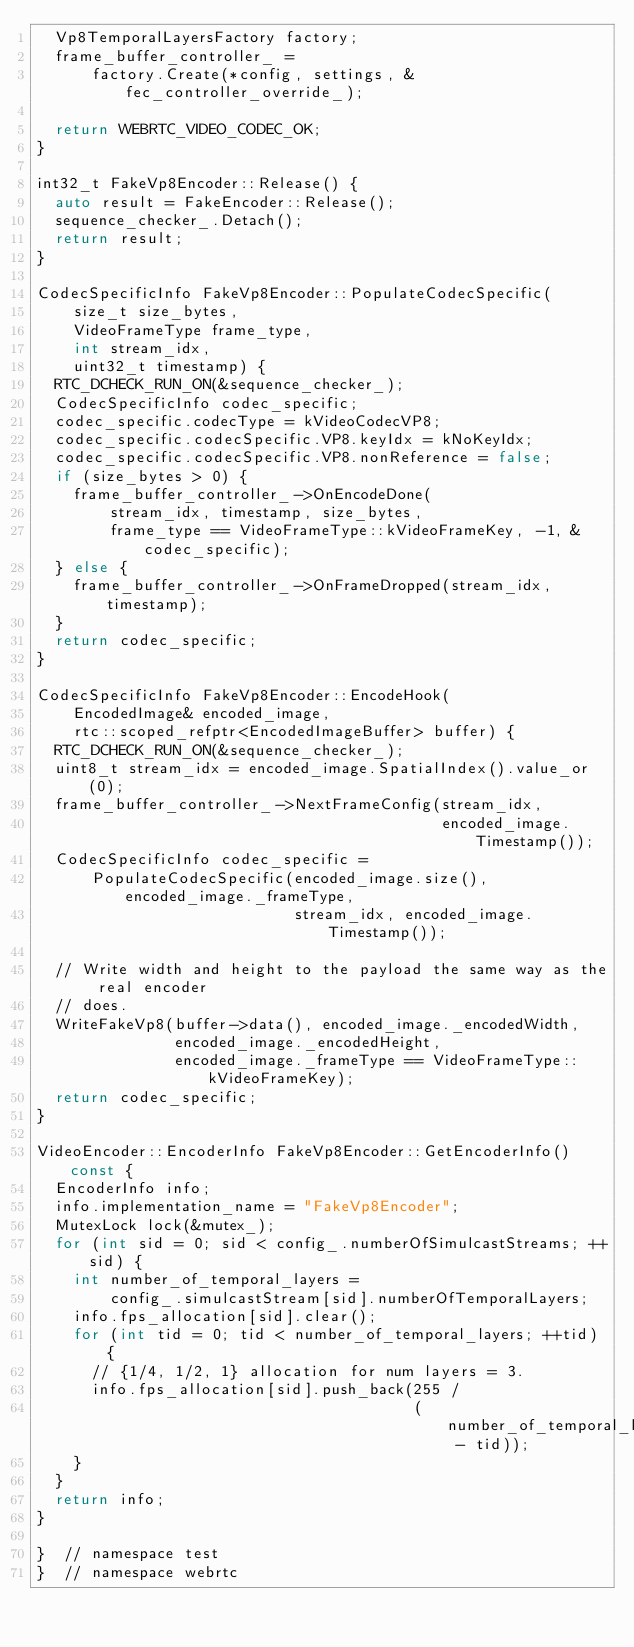Convert code to text. <code><loc_0><loc_0><loc_500><loc_500><_C++_>  Vp8TemporalLayersFactory factory;
  frame_buffer_controller_ =
      factory.Create(*config, settings, &fec_controller_override_);

  return WEBRTC_VIDEO_CODEC_OK;
}

int32_t FakeVp8Encoder::Release() {
  auto result = FakeEncoder::Release();
  sequence_checker_.Detach();
  return result;
}

CodecSpecificInfo FakeVp8Encoder::PopulateCodecSpecific(
    size_t size_bytes,
    VideoFrameType frame_type,
    int stream_idx,
    uint32_t timestamp) {
  RTC_DCHECK_RUN_ON(&sequence_checker_);
  CodecSpecificInfo codec_specific;
  codec_specific.codecType = kVideoCodecVP8;
  codec_specific.codecSpecific.VP8.keyIdx = kNoKeyIdx;
  codec_specific.codecSpecific.VP8.nonReference = false;
  if (size_bytes > 0) {
    frame_buffer_controller_->OnEncodeDone(
        stream_idx, timestamp, size_bytes,
        frame_type == VideoFrameType::kVideoFrameKey, -1, &codec_specific);
  } else {
    frame_buffer_controller_->OnFrameDropped(stream_idx, timestamp);
  }
  return codec_specific;
}

CodecSpecificInfo FakeVp8Encoder::EncodeHook(
    EncodedImage& encoded_image,
    rtc::scoped_refptr<EncodedImageBuffer> buffer) {
  RTC_DCHECK_RUN_ON(&sequence_checker_);
  uint8_t stream_idx = encoded_image.SpatialIndex().value_or(0);
  frame_buffer_controller_->NextFrameConfig(stream_idx,
                                            encoded_image.Timestamp());
  CodecSpecificInfo codec_specific =
      PopulateCodecSpecific(encoded_image.size(), encoded_image._frameType,
                            stream_idx, encoded_image.Timestamp());

  // Write width and height to the payload the same way as the real encoder
  // does.
  WriteFakeVp8(buffer->data(), encoded_image._encodedWidth,
               encoded_image._encodedHeight,
               encoded_image._frameType == VideoFrameType::kVideoFrameKey);
  return codec_specific;
}

VideoEncoder::EncoderInfo FakeVp8Encoder::GetEncoderInfo() const {
  EncoderInfo info;
  info.implementation_name = "FakeVp8Encoder";
  MutexLock lock(&mutex_);
  for (int sid = 0; sid < config_.numberOfSimulcastStreams; ++sid) {
    int number_of_temporal_layers =
        config_.simulcastStream[sid].numberOfTemporalLayers;
    info.fps_allocation[sid].clear();
    for (int tid = 0; tid < number_of_temporal_layers; ++tid) {
      // {1/4, 1/2, 1} allocation for num layers = 3.
      info.fps_allocation[sid].push_back(255 /
                                         (number_of_temporal_layers - tid));
    }
  }
  return info;
}

}  // namespace test
}  // namespace webrtc
</code> 